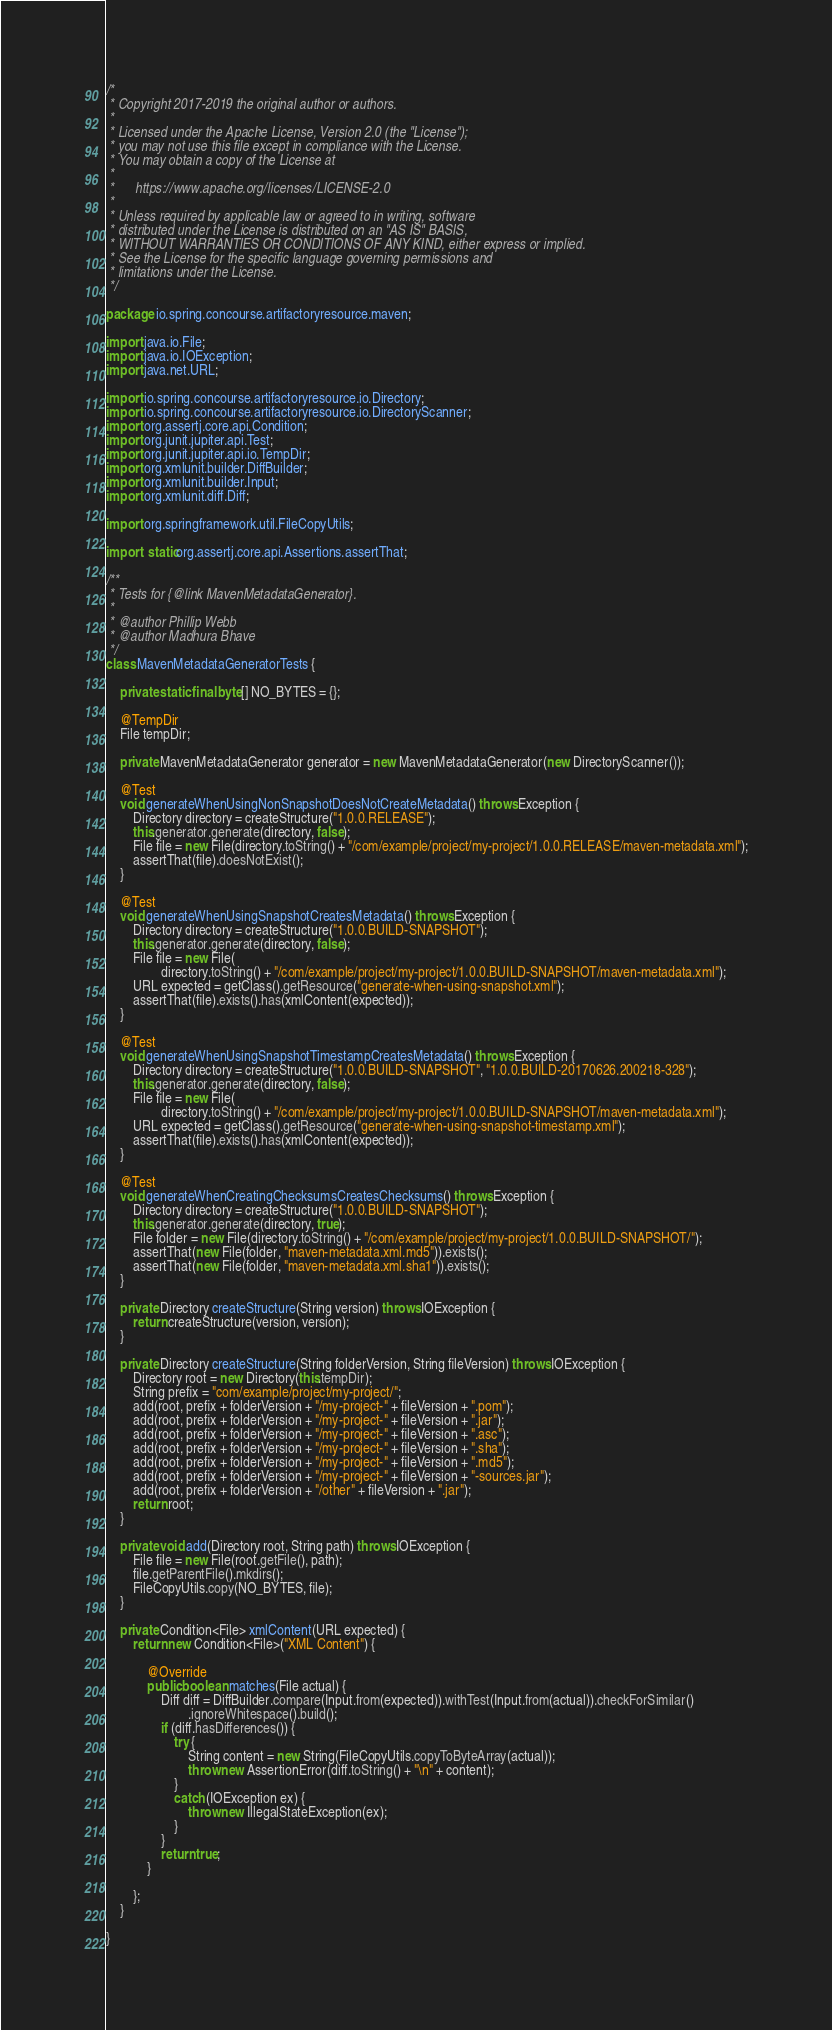Convert code to text. <code><loc_0><loc_0><loc_500><loc_500><_Java_>/*
 * Copyright 2017-2019 the original author or authors.
 *
 * Licensed under the Apache License, Version 2.0 (the "License");
 * you may not use this file except in compliance with the License.
 * You may obtain a copy of the License at
 *
 *      https://www.apache.org/licenses/LICENSE-2.0
 *
 * Unless required by applicable law or agreed to in writing, software
 * distributed under the License is distributed on an "AS IS" BASIS,
 * WITHOUT WARRANTIES OR CONDITIONS OF ANY KIND, either express or implied.
 * See the License for the specific language governing permissions and
 * limitations under the License.
 */

package io.spring.concourse.artifactoryresource.maven;

import java.io.File;
import java.io.IOException;
import java.net.URL;

import io.spring.concourse.artifactoryresource.io.Directory;
import io.spring.concourse.artifactoryresource.io.DirectoryScanner;
import org.assertj.core.api.Condition;
import org.junit.jupiter.api.Test;
import org.junit.jupiter.api.io.TempDir;
import org.xmlunit.builder.DiffBuilder;
import org.xmlunit.builder.Input;
import org.xmlunit.diff.Diff;

import org.springframework.util.FileCopyUtils;

import static org.assertj.core.api.Assertions.assertThat;

/**
 * Tests for {@link MavenMetadataGenerator}.
 *
 * @author Phillip Webb
 * @author Madhura Bhave
 */
class MavenMetadataGeneratorTests {

	private static final byte[] NO_BYTES = {};

	@TempDir
	File tempDir;

	private MavenMetadataGenerator generator = new MavenMetadataGenerator(new DirectoryScanner());

	@Test
	void generateWhenUsingNonSnapshotDoesNotCreateMetadata() throws Exception {
		Directory directory = createStructure("1.0.0.RELEASE");
		this.generator.generate(directory, false);
		File file = new File(directory.toString() + "/com/example/project/my-project/1.0.0.RELEASE/maven-metadata.xml");
		assertThat(file).doesNotExist();
	}

	@Test
	void generateWhenUsingSnapshotCreatesMetadata() throws Exception {
		Directory directory = createStructure("1.0.0.BUILD-SNAPSHOT");
		this.generator.generate(directory, false);
		File file = new File(
				directory.toString() + "/com/example/project/my-project/1.0.0.BUILD-SNAPSHOT/maven-metadata.xml");
		URL expected = getClass().getResource("generate-when-using-snapshot.xml");
		assertThat(file).exists().has(xmlContent(expected));
	}

	@Test
	void generateWhenUsingSnapshotTimestampCreatesMetadata() throws Exception {
		Directory directory = createStructure("1.0.0.BUILD-SNAPSHOT", "1.0.0.BUILD-20170626.200218-328");
		this.generator.generate(directory, false);
		File file = new File(
				directory.toString() + "/com/example/project/my-project/1.0.0.BUILD-SNAPSHOT/maven-metadata.xml");
		URL expected = getClass().getResource("generate-when-using-snapshot-timestamp.xml");
		assertThat(file).exists().has(xmlContent(expected));
	}

	@Test
	void generateWhenCreatingChecksumsCreatesChecksums() throws Exception {
		Directory directory = createStructure("1.0.0.BUILD-SNAPSHOT");
		this.generator.generate(directory, true);
		File folder = new File(directory.toString() + "/com/example/project/my-project/1.0.0.BUILD-SNAPSHOT/");
		assertThat(new File(folder, "maven-metadata.xml.md5")).exists();
		assertThat(new File(folder, "maven-metadata.xml.sha1")).exists();
	}

	private Directory createStructure(String version) throws IOException {
		return createStructure(version, version);
	}

	private Directory createStructure(String folderVersion, String fileVersion) throws IOException {
		Directory root = new Directory(this.tempDir);
		String prefix = "com/example/project/my-project/";
		add(root, prefix + folderVersion + "/my-project-" + fileVersion + ".pom");
		add(root, prefix + folderVersion + "/my-project-" + fileVersion + ".jar");
		add(root, prefix + folderVersion + "/my-project-" + fileVersion + ".asc");
		add(root, prefix + folderVersion + "/my-project-" + fileVersion + ".sha");
		add(root, prefix + folderVersion + "/my-project-" + fileVersion + ".md5");
		add(root, prefix + folderVersion + "/my-project-" + fileVersion + "-sources.jar");
		add(root, prefix + folderVersion + "/other" + fileVersion + ".jar");
		return root;
	}

	private void add(Directory root, String path) throws IOException {
		File file = new File(root.getFile(), path);
		file.getParentFile().mkdirs();
		FileCopyUtils.copy(NO_BYTES, file);
	}

	private Condition<File> xmlContent(URL expected) {
		return new Condition<File>("XML Content") {

			@Override
			public boolean matches(File actual) {
				Diff diff = DiffBuilder.compare(Input.from(expected)).withTest(Input.from(actual)).checkForSimilar()
						.ignoreWhitespace().build();
				if (diff.hasDifferences()) {
					try {
						String content = new String(FileCopyUtils.copyToByteArray(actual));
						throw new AssertionError(diff.toString() + "\n" + content);
					}
					catch (IOException ex) {
						throw new IllegalStateException(ex);
					}
				}
				return true;
			}

		};
	}

}
</code> 